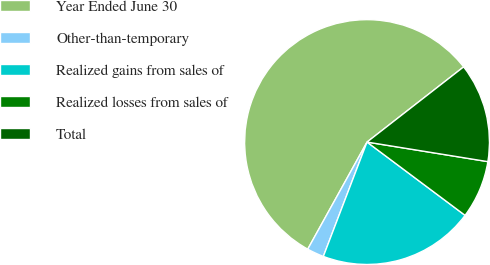Convert chart to OTSL. <chart><loc_0><loc_0><loc_500><loc_500><pie_chart><fcel>Year Ended June 30<fcel>Other-than-temporary<fcel>Realized gains from sales of<fcel>Realized losses from sales of<fcel>Total<nl><fcel>56.42%<fcel>2.24%<fcel>20.59%<fcel>7.66%<fcel>13.08%<nl></chart> 